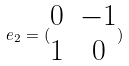<formula> <loc_0><loc_0><loc_500><loc_500>e _ { 2 } = ( \begin{matrix} 0 & - 1 \\ 1 & 0 \end{matrix} )</formula> 